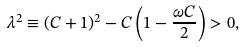Convert formula to latex. <formula><loc_0><loc_0><loc_500><loc_500>\lambda ^ { 2 } \equiv ( C + 1 ) ^ { 2 } - C \left ( 1 - \frac { \omega C } { 2 } \right ) > 0 ,</formula> 